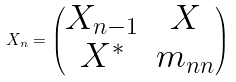Convert formula to latex. <formula><loc_0><loc_0><loc_500><loc_500>X _ { n } = \begin{pmatrix} X _ { n - 1 } & X \\ X ^ { * } & m _ { n n } \end{pmatrix}</formula> 